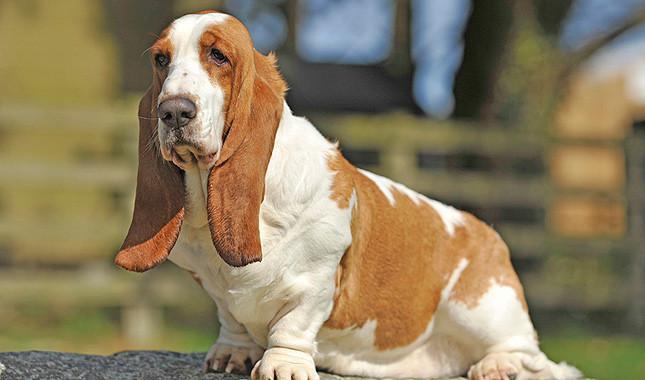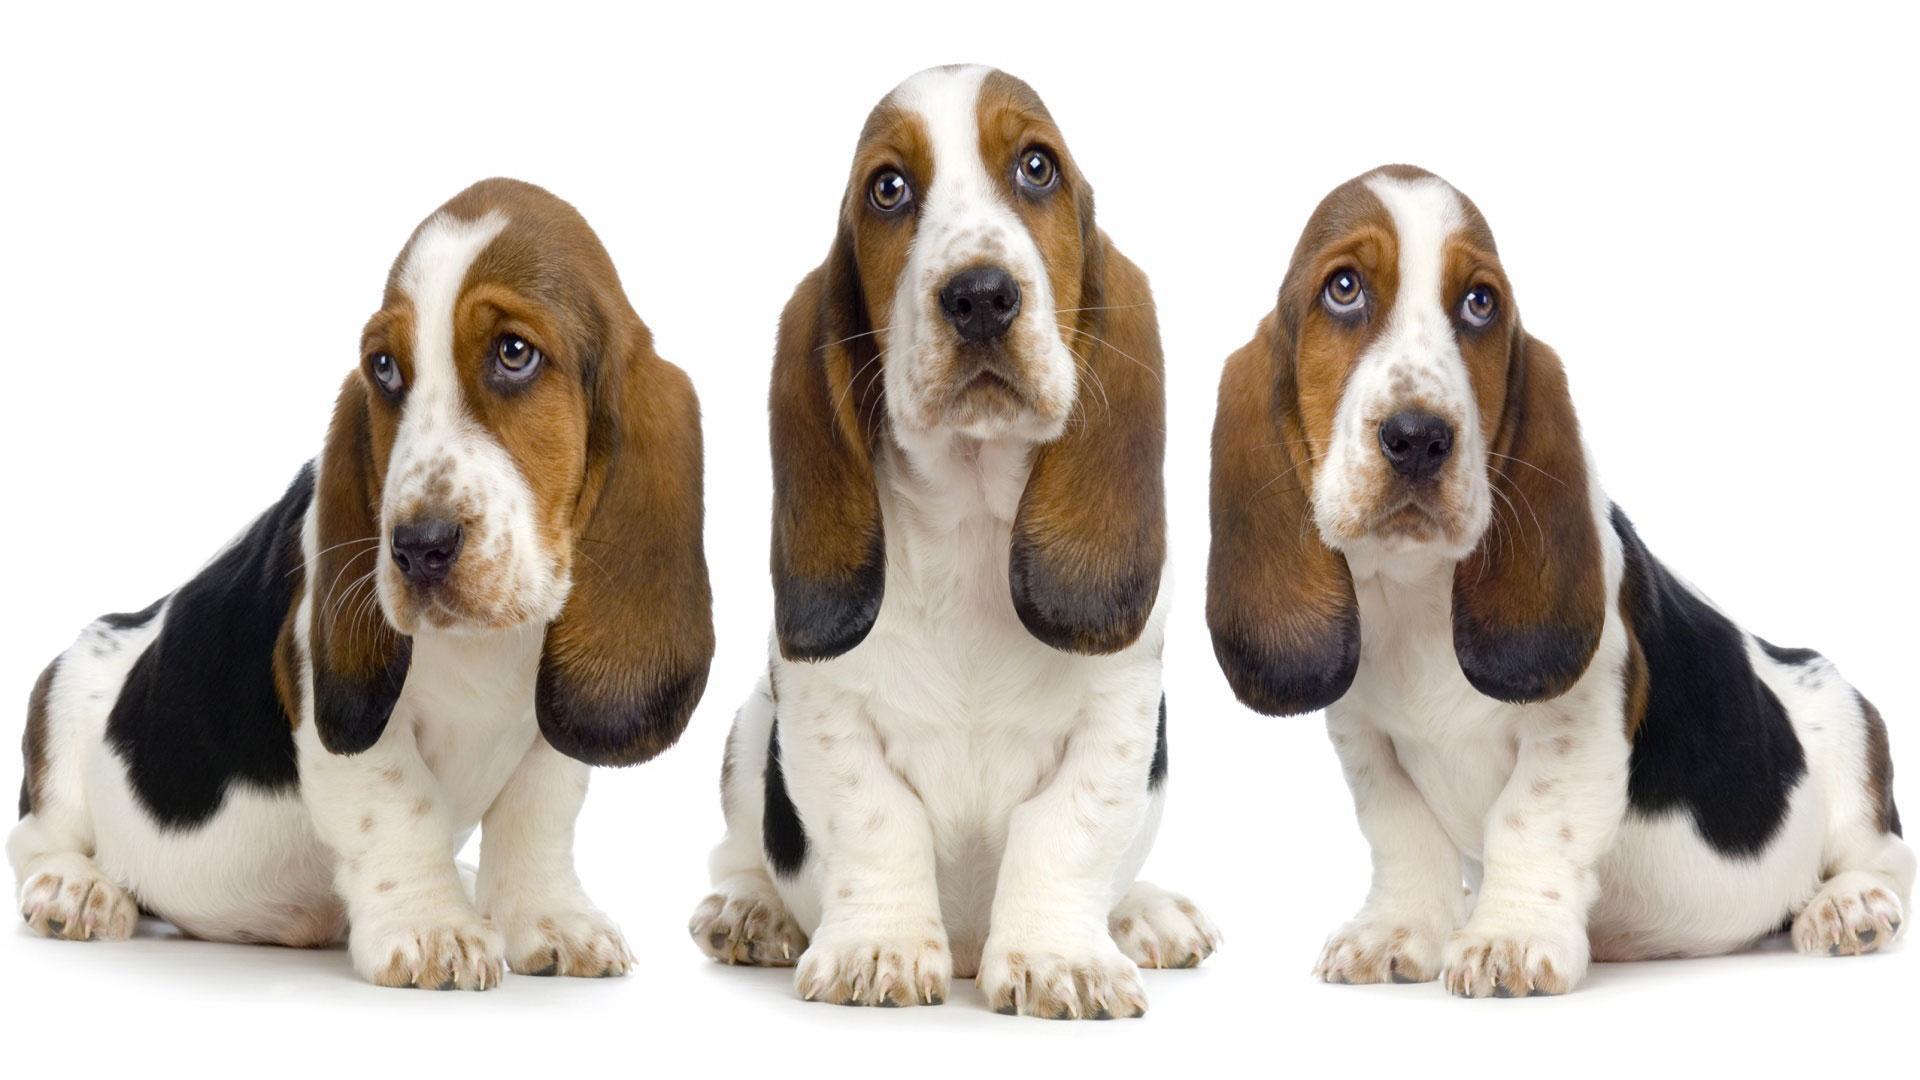The first image is the image on the left, the second image is the image on the right. Given the left and right images, does the statement "There are two dogs in total." hold true? Answer yes or no. No. 